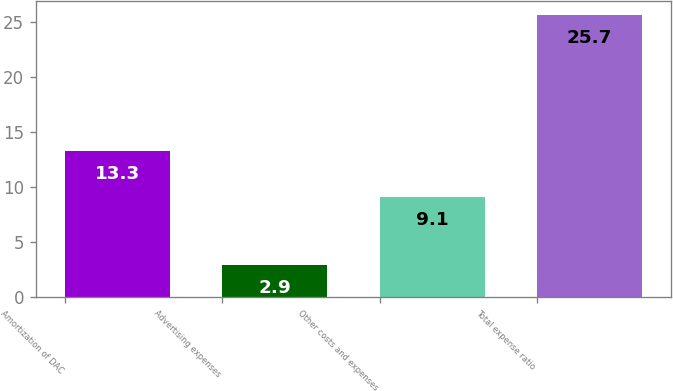<chart> <loc_0><loc_0><loc_500><loc_500><bar_chart><fcel>Amortization of DAC<fcel>Advertising expenses<fcel>Other costs and expenses<fcel>Total expense ratio<nl><fcel>13.3<fcel>2.9<fcel>9.1<fcel>25.7<nl></chart> 